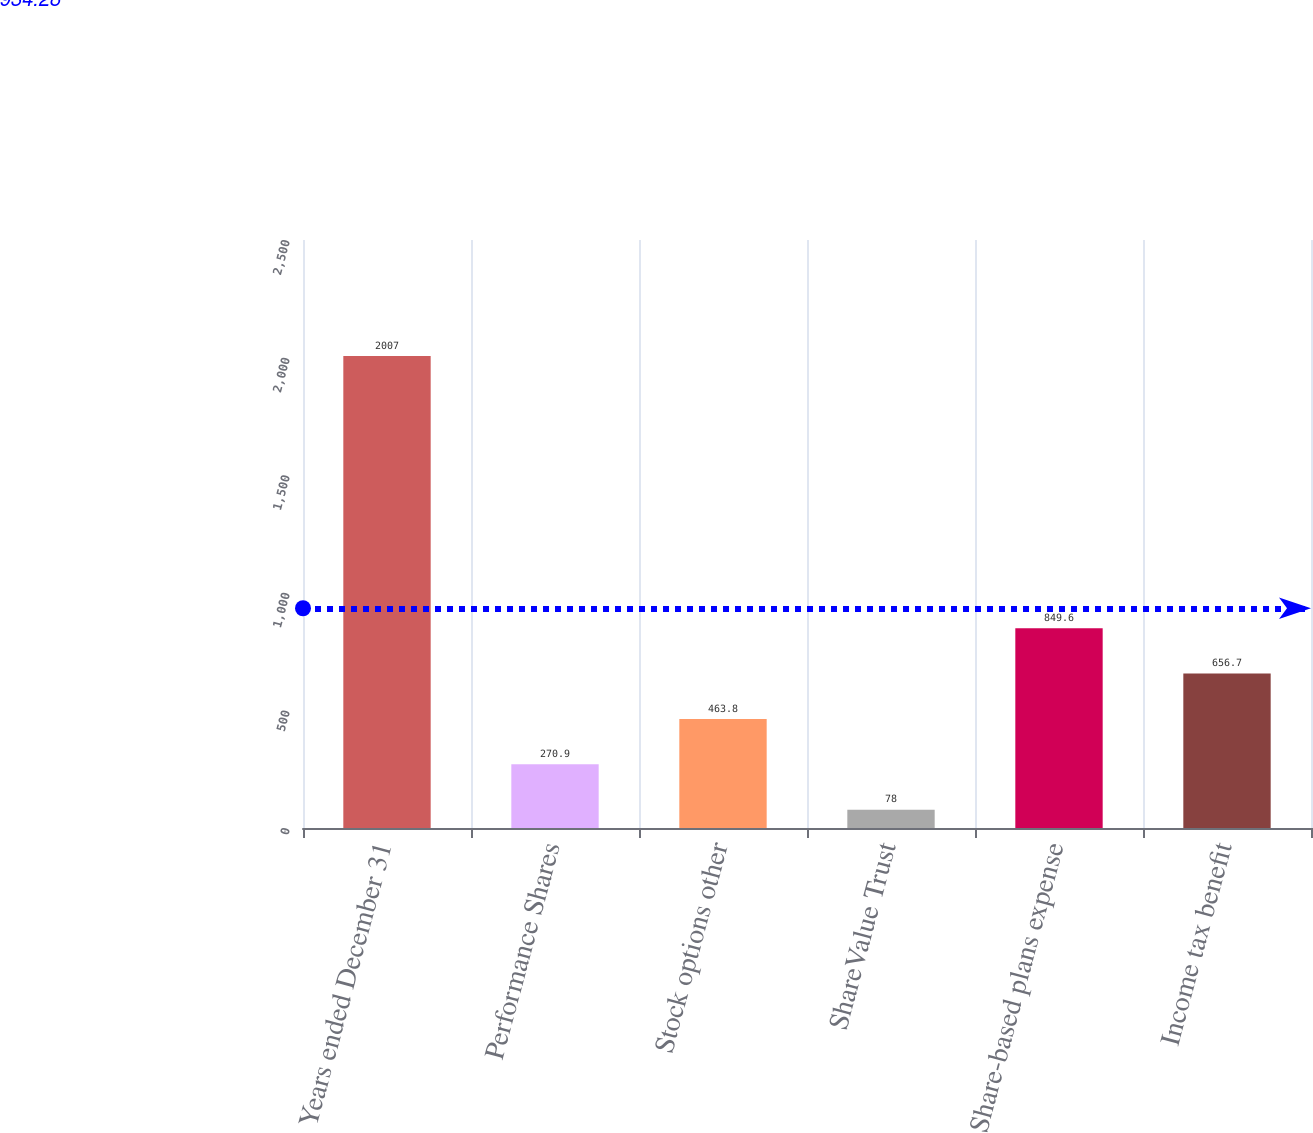Convert chart. <chart><loc_0><loc_0><loc_500><loc_500><bar_chart><fcel>Years ended December 31<fcel>Performance Shares<fcel>Stock options other<fcel>ShareValue Trust<fcel>Share-based plans expense<fcel>Income tax benefit<nl><fcel>2007<fcel>270.9<fcel>463.8<fcel>78<fcel>849.6<fcel>656.7<nl></chart> 